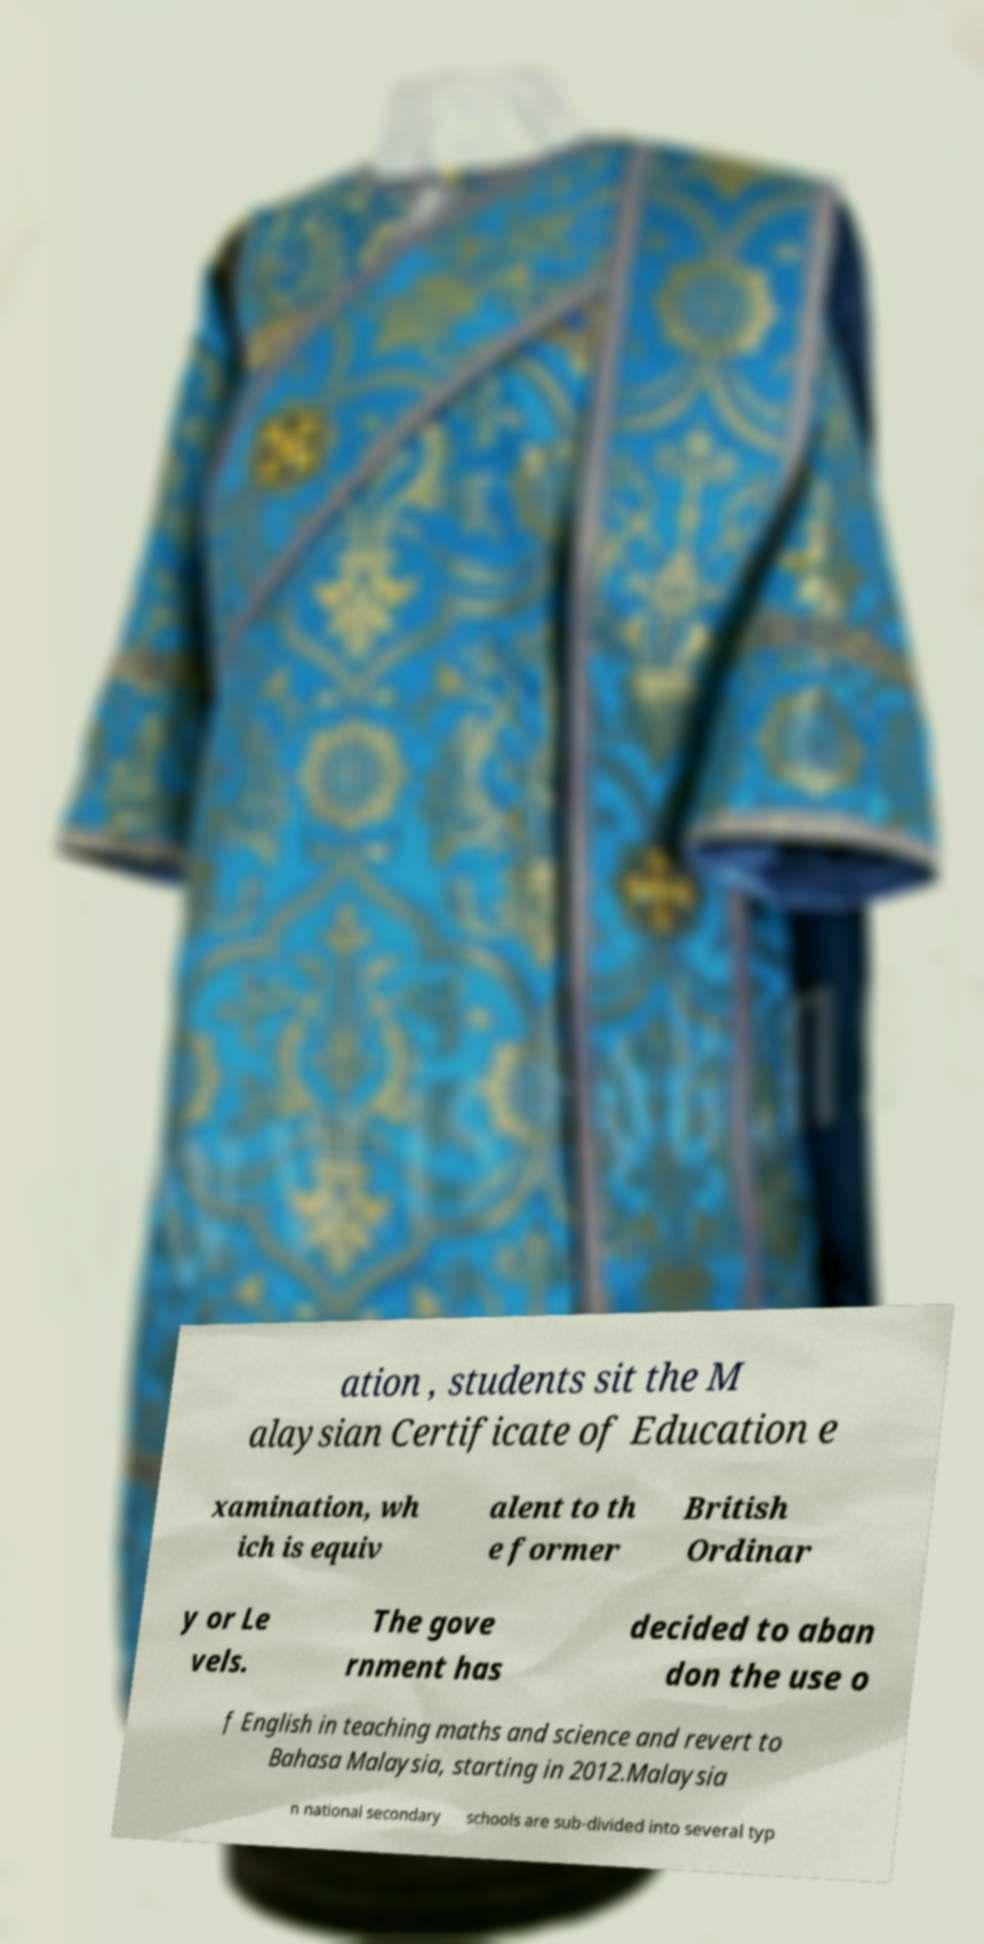Can you accurately transcribe the text from the provided image for me? ation , students sit the M alaysian Certificate of Education e xamination, wh ich is equiv alent to th e former British Ordinar y or Le vels. The gove rnment has decided to aban don the use o f English in teaching maths and science and revert to Bahasa Malaysia, starting in 2012.Malaysia n national secondary schools are sub-divided into several typ 